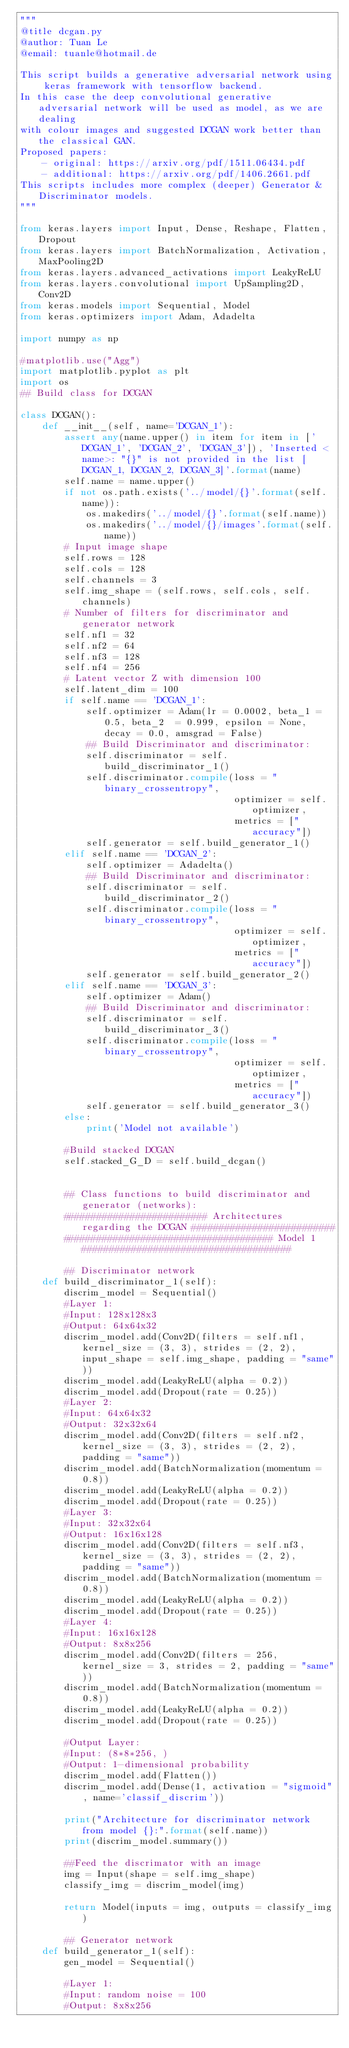Convert code to text. <code><loc_0><loc_0><loc_500><loc_500><_Python_>"""
@title dcgan.py
@author: Tuan Le
@email: tuanle@hotmail.de

This script builds a generative adversarial network using keras framework with tensorflow backend.
In this case the deep convolutional generative adversarial network will be used as model, as we are dealing
with colour images and suggested DCGAN work better than the classical GAN.
Proposed papers:
    - original: https://arxiv.org/pdf/1511.06434.pdf
    - additional: https://arxiv.org/pdf/1406.2661.pdf
This scripts includes more complex (deeper) Generator & Discriminator models.
"""

from keras.layers import Input, Dense, Reshape, Flatten, Dropout
from keras.layers import BatchNormalization, Activation, MaxPooling2D
from keras.layers.advanced_activations import LeakyReLU
from keras.layers.convolutional import UpSampling2D, Conv2D
from keras.models import Sequential, Model
from keras.optimizers import Adam, Adadelta

import numpy as np

#matplotlib.use("Agg")
import matplotlib.pyplot as plt
import os
## Build class for DCGAN

class DCGAN():
    def __init__(self, name='DCGAN_1'):
        assert any(name.upper() in item for item in ['DCGAN_1', 'DCGAN_2', 'DCGAN_3']), 'Inserted <name>: "{}" is not provided in the list [DCGAN_1, DCGAN_2, DCGAN_3]'.format(name)
        self.name = name.upper()
        if not os.path.exists('../model/{}'.format(self.name)):
            os.makedirs('../model/{}'.format(self.name))
            os.makedirs('../model/{}/images'.format(self.name))
        # Input image shape
        self.rows = 128
        self.cols = 128
        self.channels = 3
        self.img_shape = (self.rows, self.cols, self.channels)
        # Number of filters for discriminator and generator network
        self.nf1 = 32
        self.nf2 = 64
        self.nf3 = 128
        self.nf4 = 256
        # Latent vector Z with dimension 100
        self.latent_dim = 100
        if self.name == 'DCGAN_1': 
            self.optimizer = Adam(lr = 0.0002, beta_1 = 0.5, beta_2  = 0.999, epsilon = None, decay = 0.0, amsgrad = False)
            ## Build Discriminator and discriminator:
            self.discriminator = self.build_discriminator_1()
            self.discriminator.compile(loss = "binary_crossentropy",
                                       optimizer = self.optimizer,
                                       metrics = ["accuracy"])
            self.generator = self.build_generator_1()
        elif self.name == 'DCGAN_2':
            self.optimizer = Adadelta()
            ## Build Discriminator and discriminator:
            self.discriminator = self.build_discriminator_2()
            self.discriminator.compile(loss = "binary_crossentropy",
                                       optimizer = self.optimizer,
                                       metrics = ["accuracy"])
            self.generator = self.build_generator_2()
        elif self.name == 'DCGAN_3':
            self.optimizer = Adam()
            ## Build Discriminator and discriminator:
            self.discriminator = self.build_discriminator_3()
            self.discriminator.compile(loss = "binary_crossentropy",
                                       optimizer = self.optimizer,
                                       metrics = ["accuracy"])
            self.generator = self.build_generator_3()
        else:
            print('Model not available')
            
        #Build stacked DCGAN
        self.stacked_G_D = self.build_dcgan()
        
        
        ## Class functions to build discriminator and generator (networks):
        ########################## Architectures regarding the DCGAN ##########################
        ###################################### Model 1 ######################################
        
        ## Discriminator network
    def build_discriminator_1(self):
        discrim_model = Sequential()
        #Layer 1:
        #Input: 128x128x3
        #Output: 64x64x32
        discrim_model.add(Conv2D(filters = self.nf1, kernel_size = (3, 3), strides = (2, 2), input_shape = self.img_shape, padding = "same"))
        discrim_model.add(LeakyReLU(alpha = 0.2))
        discrim_model.add(Dropout(rate = 0.25))
        #Layer 2:
        #Input: 64x64x32
        #Output: 32x32x64
        discrim_model.add(Conv2D(filters = self.nf2, kernel_size = (3, 3), strides = (2, 2), padding = "same"))
        discrim_model.add(BatchNormalization(momentum = 0.8))
        discrim_model.add(LeakyReLU(alpha = 0.2))
        discrim_model.add(Dropout(rate = 0.25))
        #Layer 3:
        #Input: 32x32x64
        #Output: 16x16x128
        discrim_model.add(Conv2D(filters = self.nf3, kernel_size = (3, 3), strides = (2, 2), padding = "same"))
        discrim_model.add(BatchNormalization(momentum = 0.8))
        discrim_model.add(LeakyReLU(alpha = 0.2))
        discrim_model.add(Dropout(rate = 0.25))
        #Layer 4:
        #Input: 16x16x128
        #Output: 8x8x256
        discrim_model.add(Conv2D(filters = 256, kernel_size = 3, strides = 2, padding = "same"))
        discrim_model.add(BatchNormalization(momentum = 0.8))
        discrim_model.add(LeakyReLU(alpha = 0.2))
        discrim_model.add(Dropout(rate = 0.25))
        
        #Output Layer: 
        #Input: (8*8*256, )
        #Output: 1-dimensional probability
        discrim_model.add(Flatten())
        discrim_model.add(Dense(1, activation = "sigmoid", name='classif_discrim'))

        print("Architecture for discriminator network from model {}:".format(self.name))
        print(discrim_model.summary())

        ##Feed the discrimator with an image
        img = Input(shape = self.img_shape)
        classify_img = discrim_model(img)

        return Model(inputs = img, outputs = classify_img)

        ## Generator network
    def build_generator_1(self):
        gen_model = Sequential()

        #Layer 1:
        #Input: random noise = 100
        #Output: 8x8x256</code> 